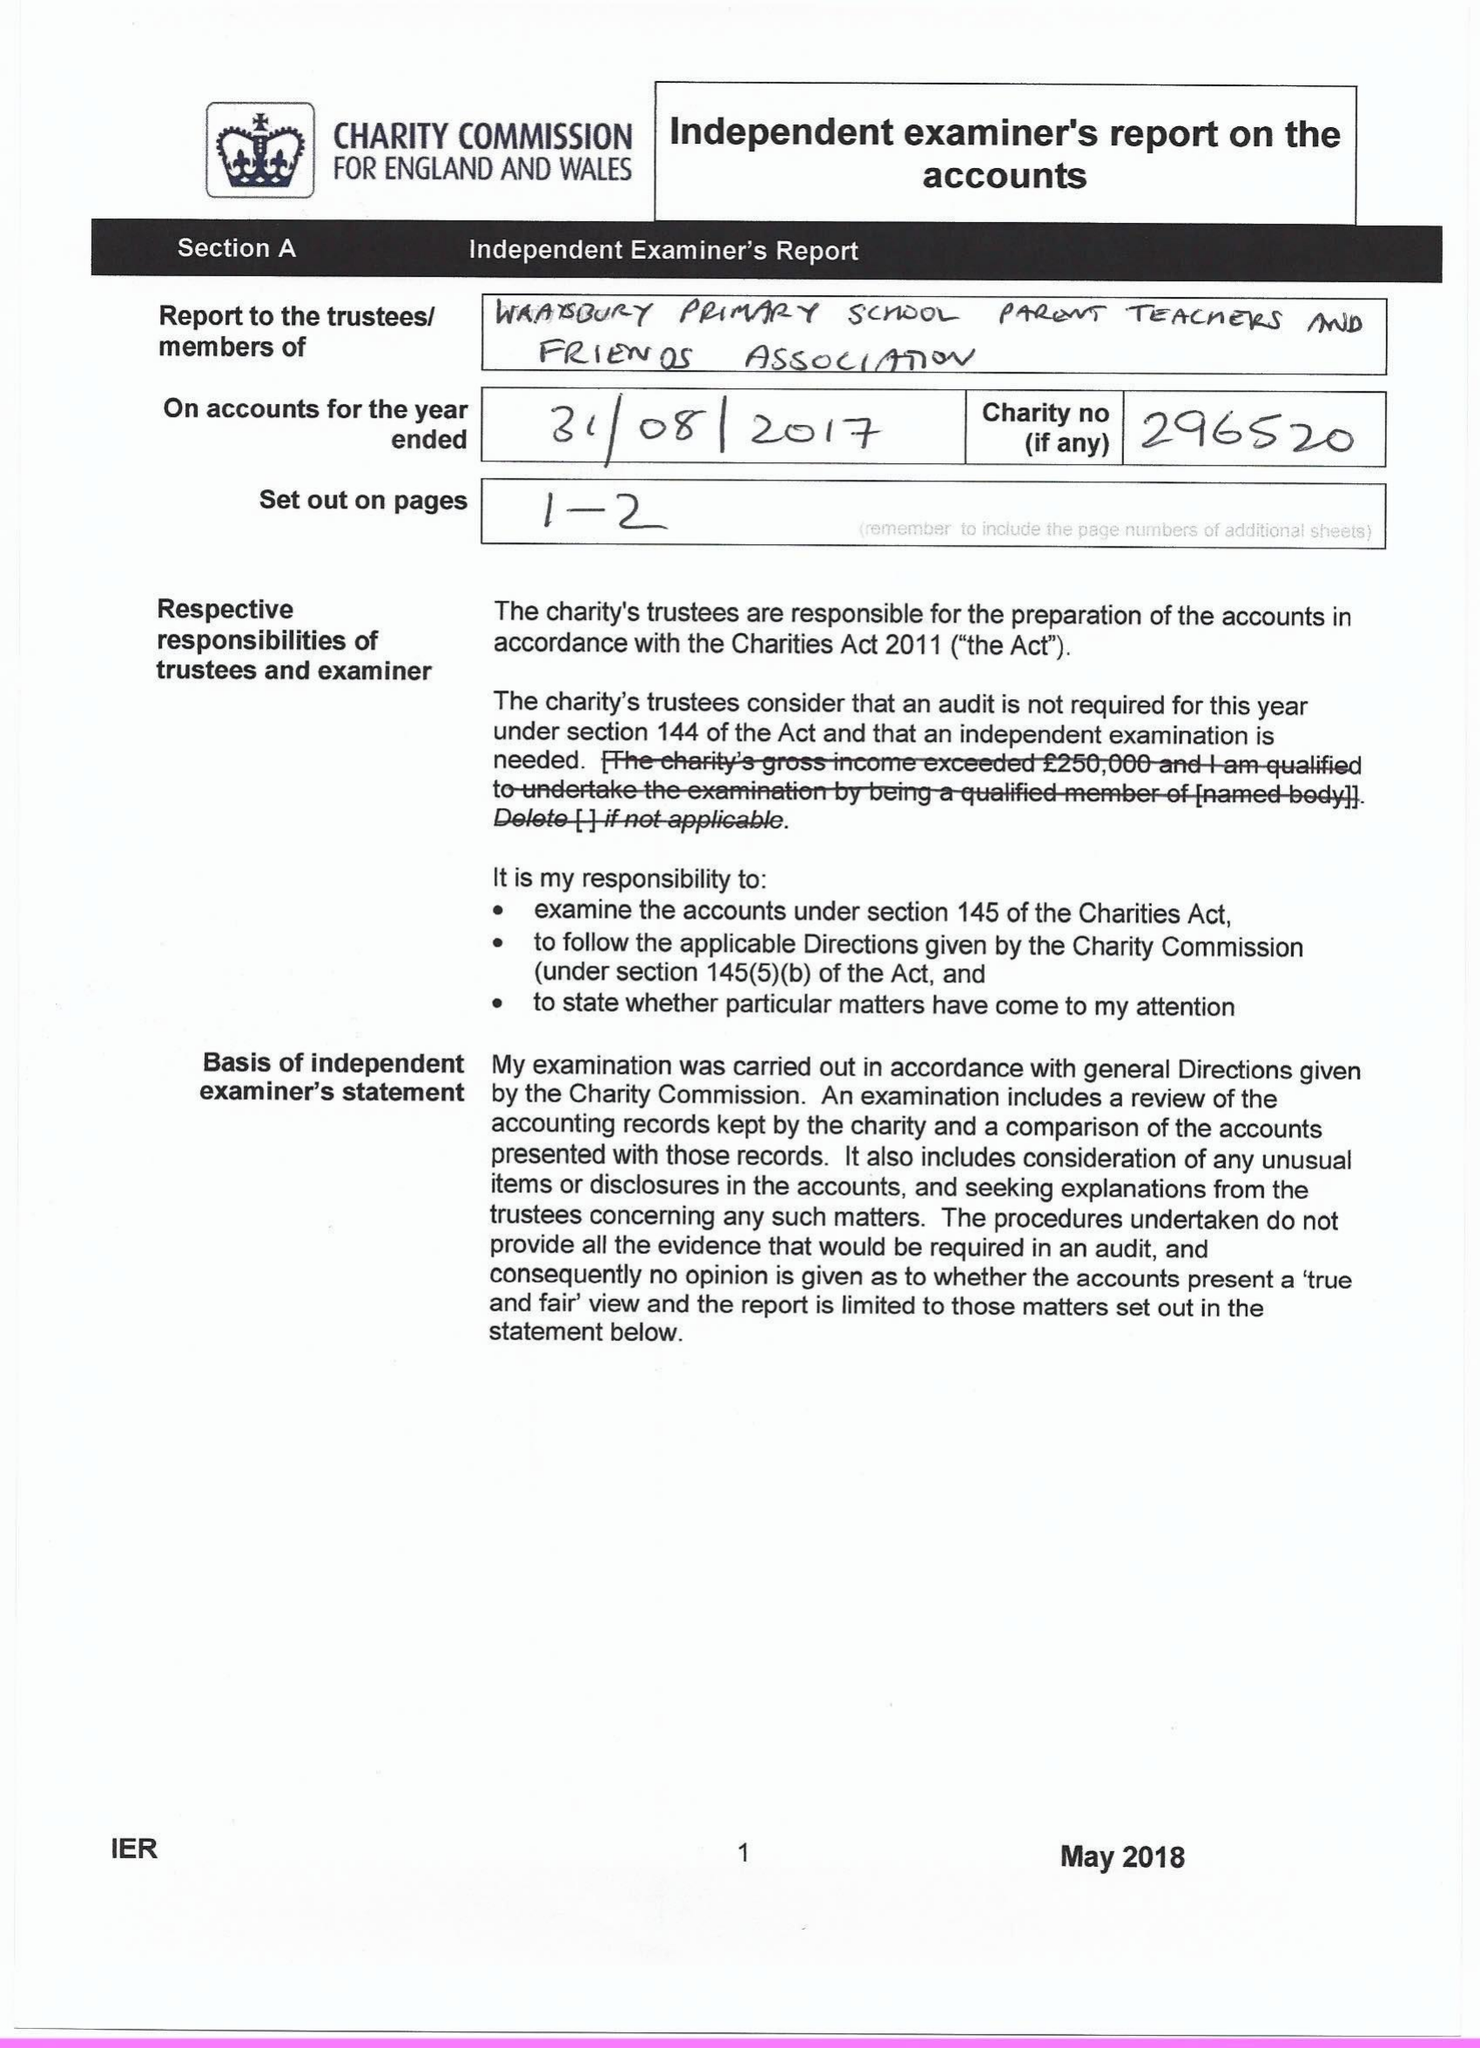What is the value for the address__post_town?
Answer the question using a single word or phrase. STAINES-UPON-THAMES[11] 